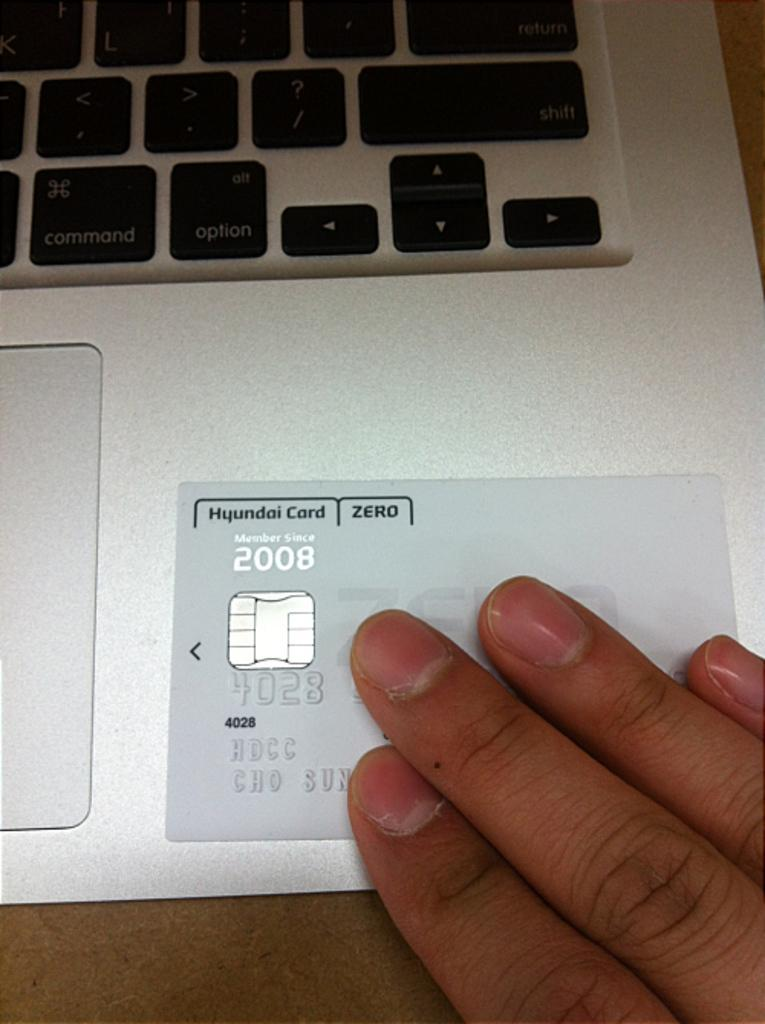<image>
Create a compact narrative representing the image presented. A person's hand is on a Hyundai Card that is sitting on a laptop computer. 